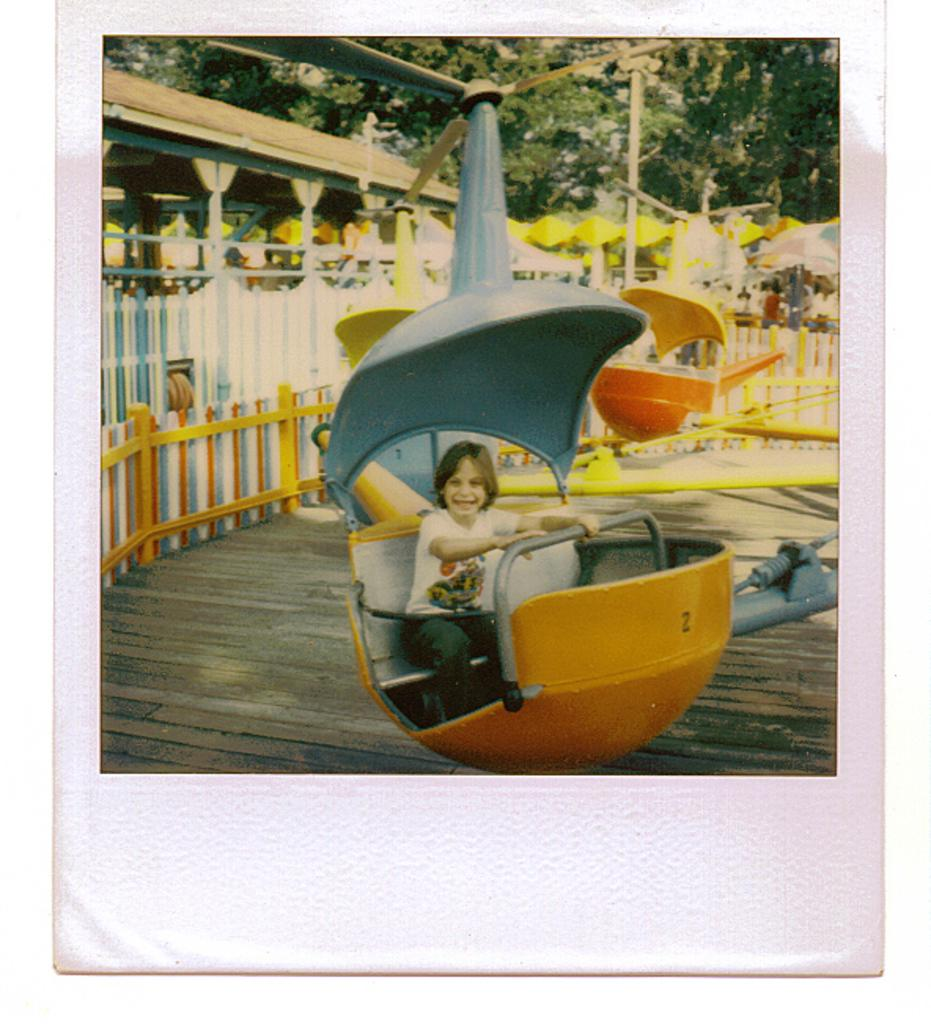What is the child doing in the image? The child is sitting on a ride in the image. How does the child appear to feel while on the ride? The child is smiling, which suggests they are enjoying the ride. What is the ride situated on? The ride is on a wooden platform. What can be seen in the background of the image? There are trees and fencing in the background of the image. What type of pear is being used to draw on the wooden platform in the image? There is no pear or drawing activity present in the image. How many cakes are visible on the ride in the image? There are no cakes present in the image; it features a child sitting on a ride. 